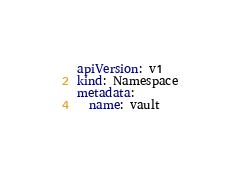Convert code to text. <code><loc_0><loc_0><loc_500><loc_500><_YAML_>apiVersion: v1
kind: Namespace
metadata:
  name: vault</code> 